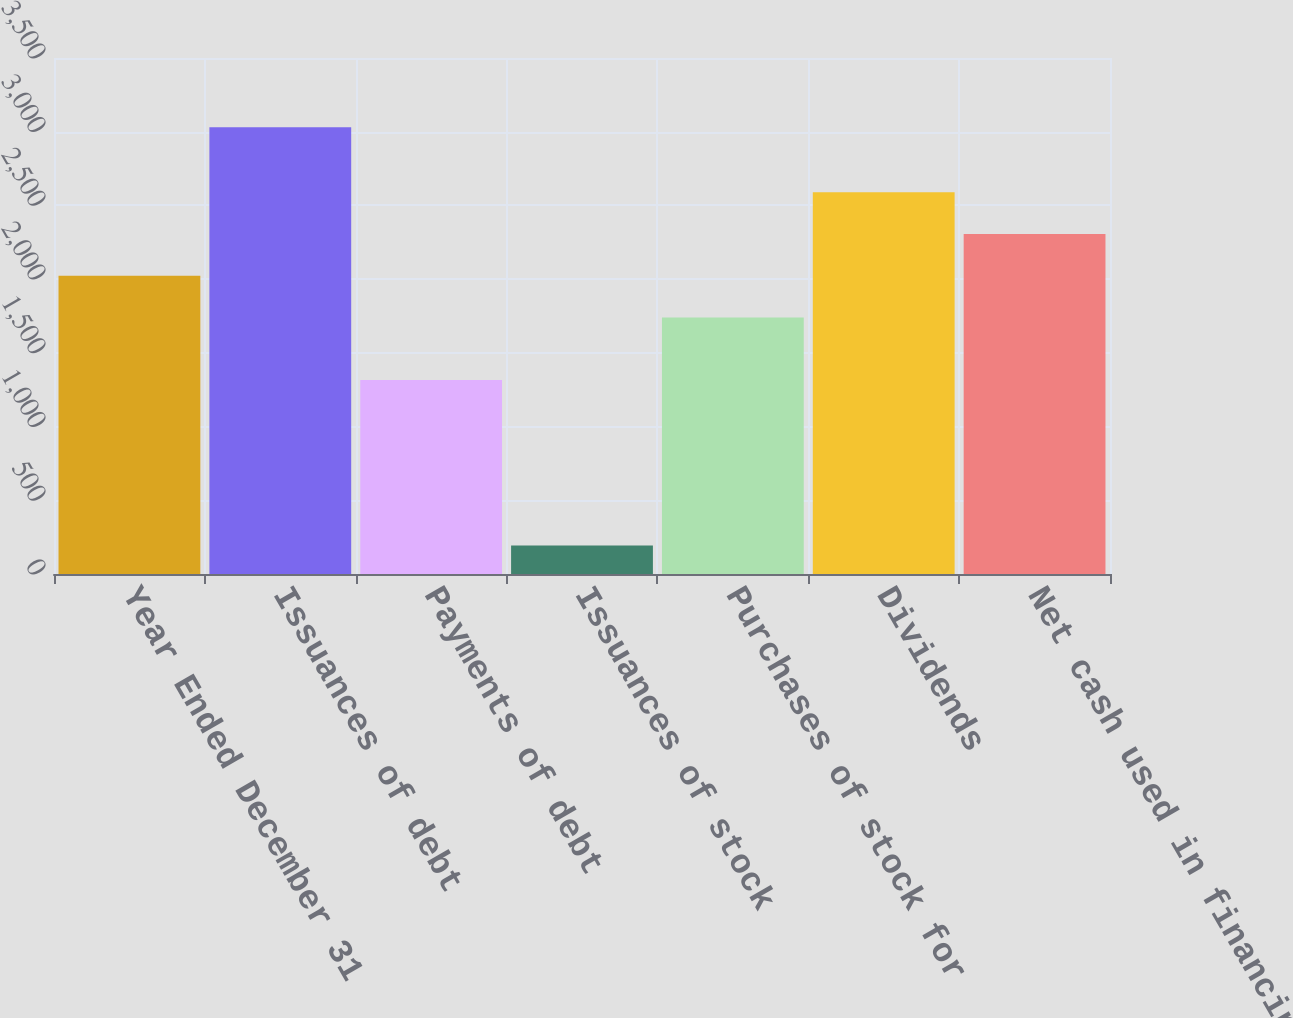Convert chart. <chart><loc_0><loc_0><loc_500><loc_500><bar_chart><fcel>Year Ended December 31<fcel>Issuances of debt<fcel>Payments of debt<fcel>Issuances of stock<fcel>Purchases of stock for<fcel>Dividends<fcel>Net cash used in financing<nl><fcel>2022.7<fcel>3030<fcel>1316<fcel>193<fcel>1739<fcel>2590.1<fcel>2306.4<nl></chart> 